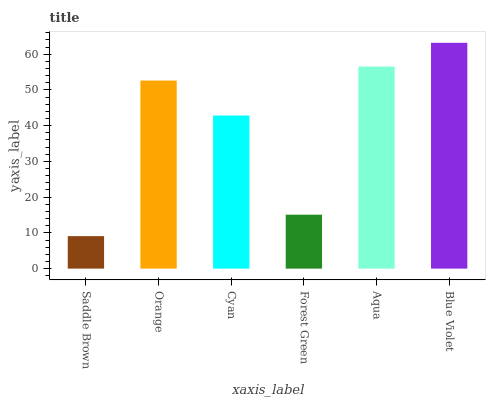Is Saddle Brown the minimum?
Answer yes or no. Yes. Is Blue Violet the maximum?
Answer yes or no. Yes. Is Orange the minimum?
Answer yes or no. No. Is Orange the maximum?
Answer yes or no. No. Is Orange greater than Saddle Brown?
Answer yes or no. Yes. Is Saddle Brown less than Orange?
Answer yes or no. Yes. Is Saddle Brown greater than Orange?
Answer yes or no. No. Is Orange less than Saddle Brown?
Answer yes or no. No. Is Orange the high median?
Answer yes or no. Yes. Is Cyan the low median?
Answer yes or no. Yes. Is Saddle Brown the high median?
Answer yes or no. No. Is Forest Green the low median?
Answer yes or no. No. 